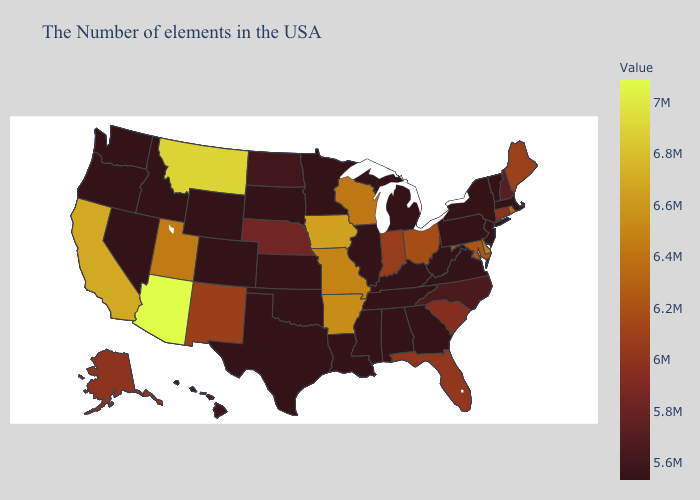Among the states that border Texas , which have the highest value?
Keep it brief. Arkansas. Does New Mexico have the lowest value in the USA?
Concise answer only. No. Does Arizona have the highest value in the USA?
Keep it brief. Yes. Which states have the lowest value in the USA?
Short answer required. Massachusetts, Vermont, New Jersey, Pennsylvania, Virginia, West Virginia, Georgia, Michigan, Kentucky, Alabama, Tennessee, Illinois, Mississippi, Louisiana, Minnesota, Kansas, Oklahoma, Texas, South Dakota, Wyoming, Colorado, Idaho, Nevada, Washington, Oregon. 